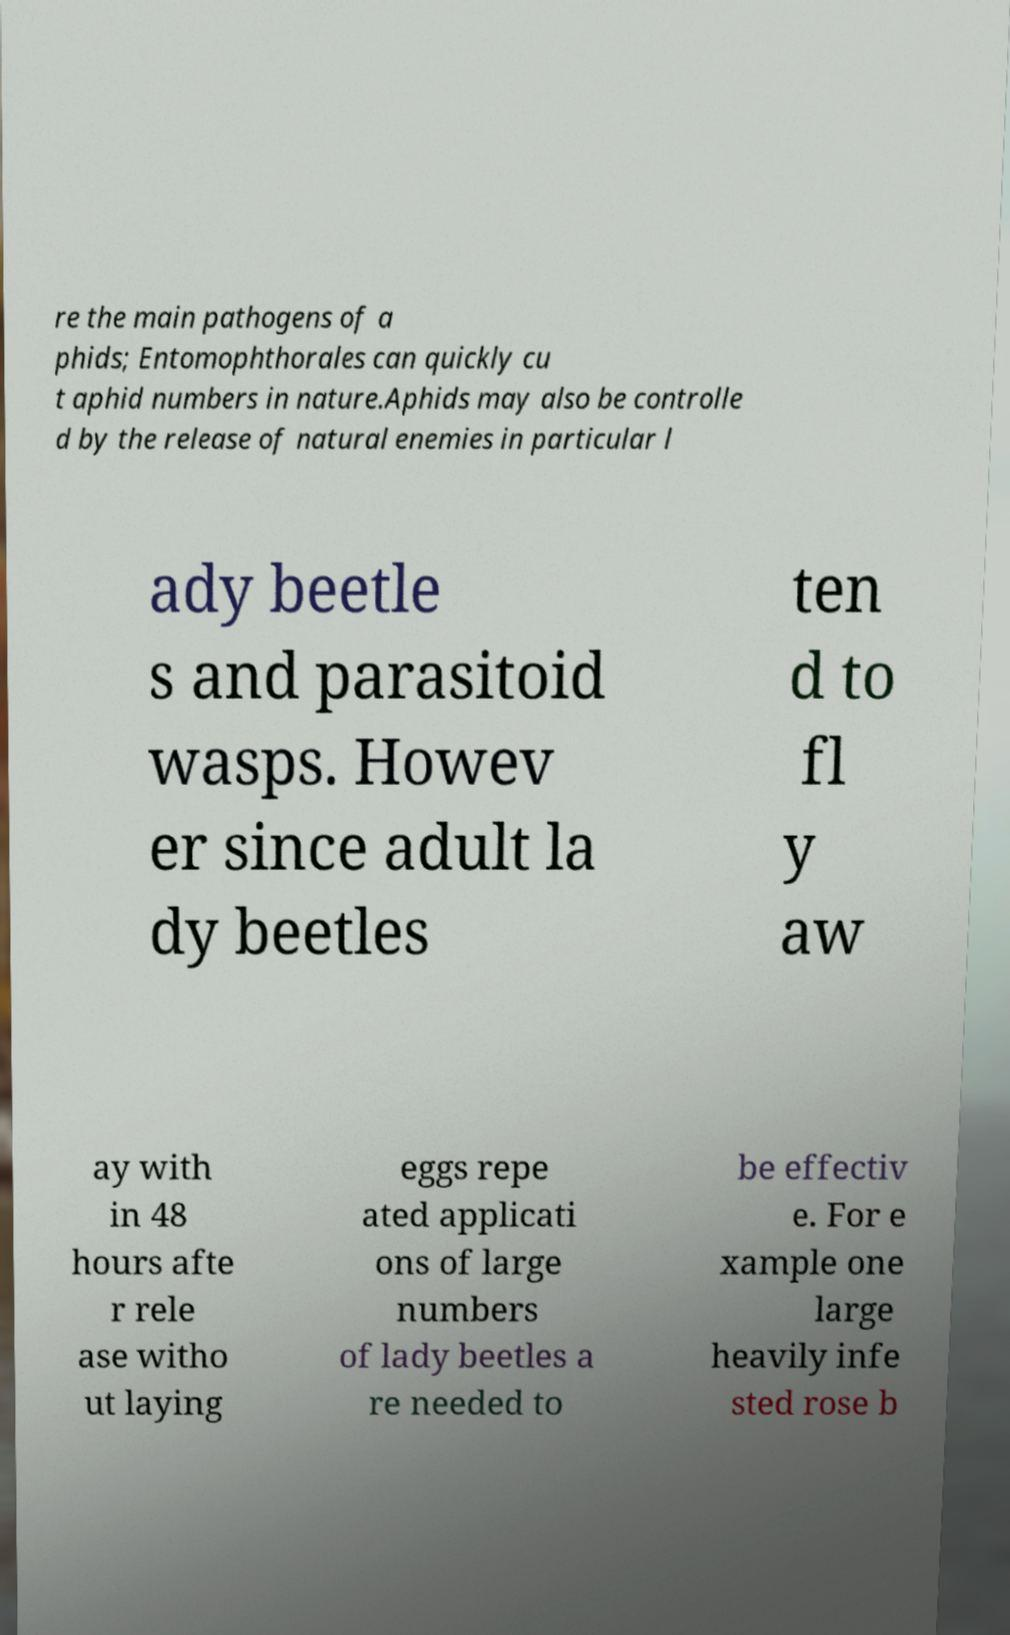Please read and relay the text visible in this image. What does it say? re the main pathogens of a phids; Entomophthorales can quickly cu t aphid numbers in nature.Aphids may also be controlle d by the release of natural enemies in particular l ady beetle s and parasitoid wasps. Howev er since adult la dy beetles ten d to fl y aw ay with in 48 hours afte r rele ase witho ut laying eggs repe ated applicati ons of large numbers of lady beetles a re needed to be effectiv e. For e xample one large heavily infe sted rose b 